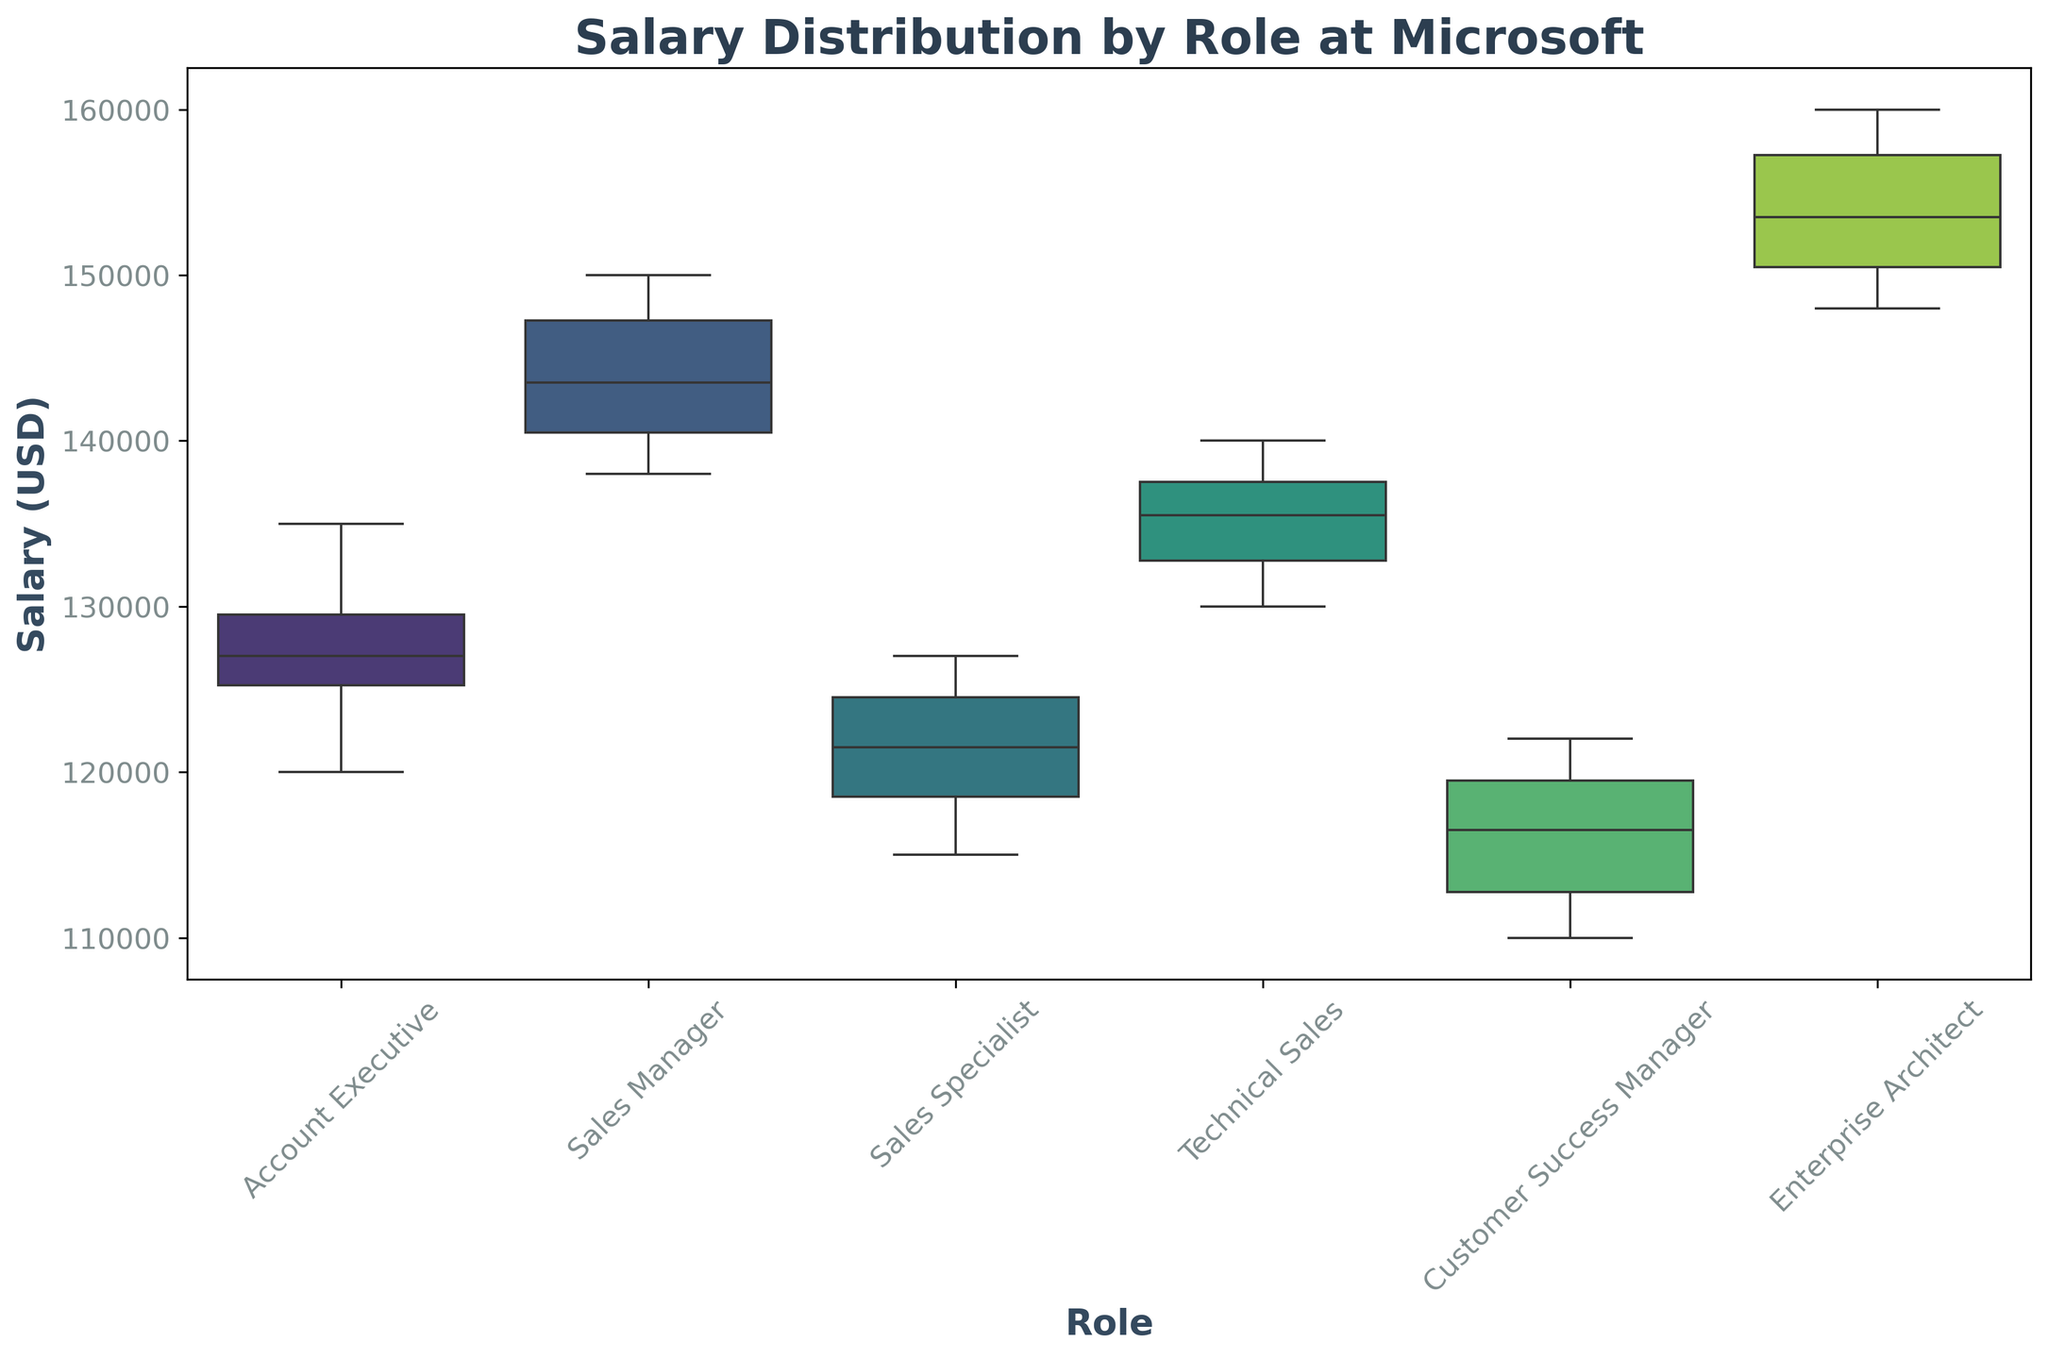What is the median salary for Sales Specialists? The median salary is the middle value in a sorted list of salaries. For Sales Specialists, the middle values are 120000 and 123000, thus the median is the average of these two values.
Answer: 121500 How does the range of salaries for Sales Managers compare to that of Account Executives? The range is the difference between the highest and lowest values. For Sales Managers, the range is 150000 - 138000 = 12000. For Account Executives, the range is 135000 - 120000 = 15000. Comparing 12000 to 15000, we see that Account Executives have a wider range of salaries.
Answer: Account Executives have a wider range Which role has the highest median salary? By looking at the middle line inside the boxes representing the median value, the role with the highest median line is the Enterprise Architect.
Answer: Enterprise Architect Are the salaries for Technical Sales generally higher than those for Customer Success Managers? To determine this, compare the vertical positions of the boxes. The boxes for Technical Sales are higher on the y-axis compared to those for Customer Success Managers, indicating generally higher salaries.
Answer: Yes What is the interquartile range (IQR) for the salary of Enterprise Architects? The IQR is the difference between the third quartile (Q3) and the first quartile (Q1). For Enterprise Architects, this can be visually approximated by the length of the box.
Answer: Approx. 8000 (Visual estimation) Which role has the smallest variation in salary? The smallest box indicates the smallest variation. The role with the smallest box is likely Customer Success Manager, indicating the least variation in salary.
Answer: Customer Success Manager Is there any role where the median salary is outside the interquartile range? The median should be inside the box (IQR), if not then it's outside. All median lines are within their respective boxes, so no role has the median salary outside the IQR.
Answer: No Which role has the lowest maximum salary? The maximum salary is identified by the top whisker. The role with the lower top whisker is Customer Success Manager.
Answer: Customer Success Manager How does the upper quartile for Sales Specialists compare to that for Sales Managers? The upper quartile (Q3) can be estimated by the top edge of the box. Compare the height of these edges for Sales Specialists and Sales Managers. Sales Managers have a higher Q3 than Sales Specialists.
Answer: Sales Managers have a higher upper quartile What is the difference between the maximum salary of Technical Sales and Sales Managers? Find the top whiskers for Technical Sales and Sales Managers. For Technical Sales, the max is 140000 and for Sales Managers, it is 150000. The difference is 150000 - 140000 = 10000.
Answer: 10000 